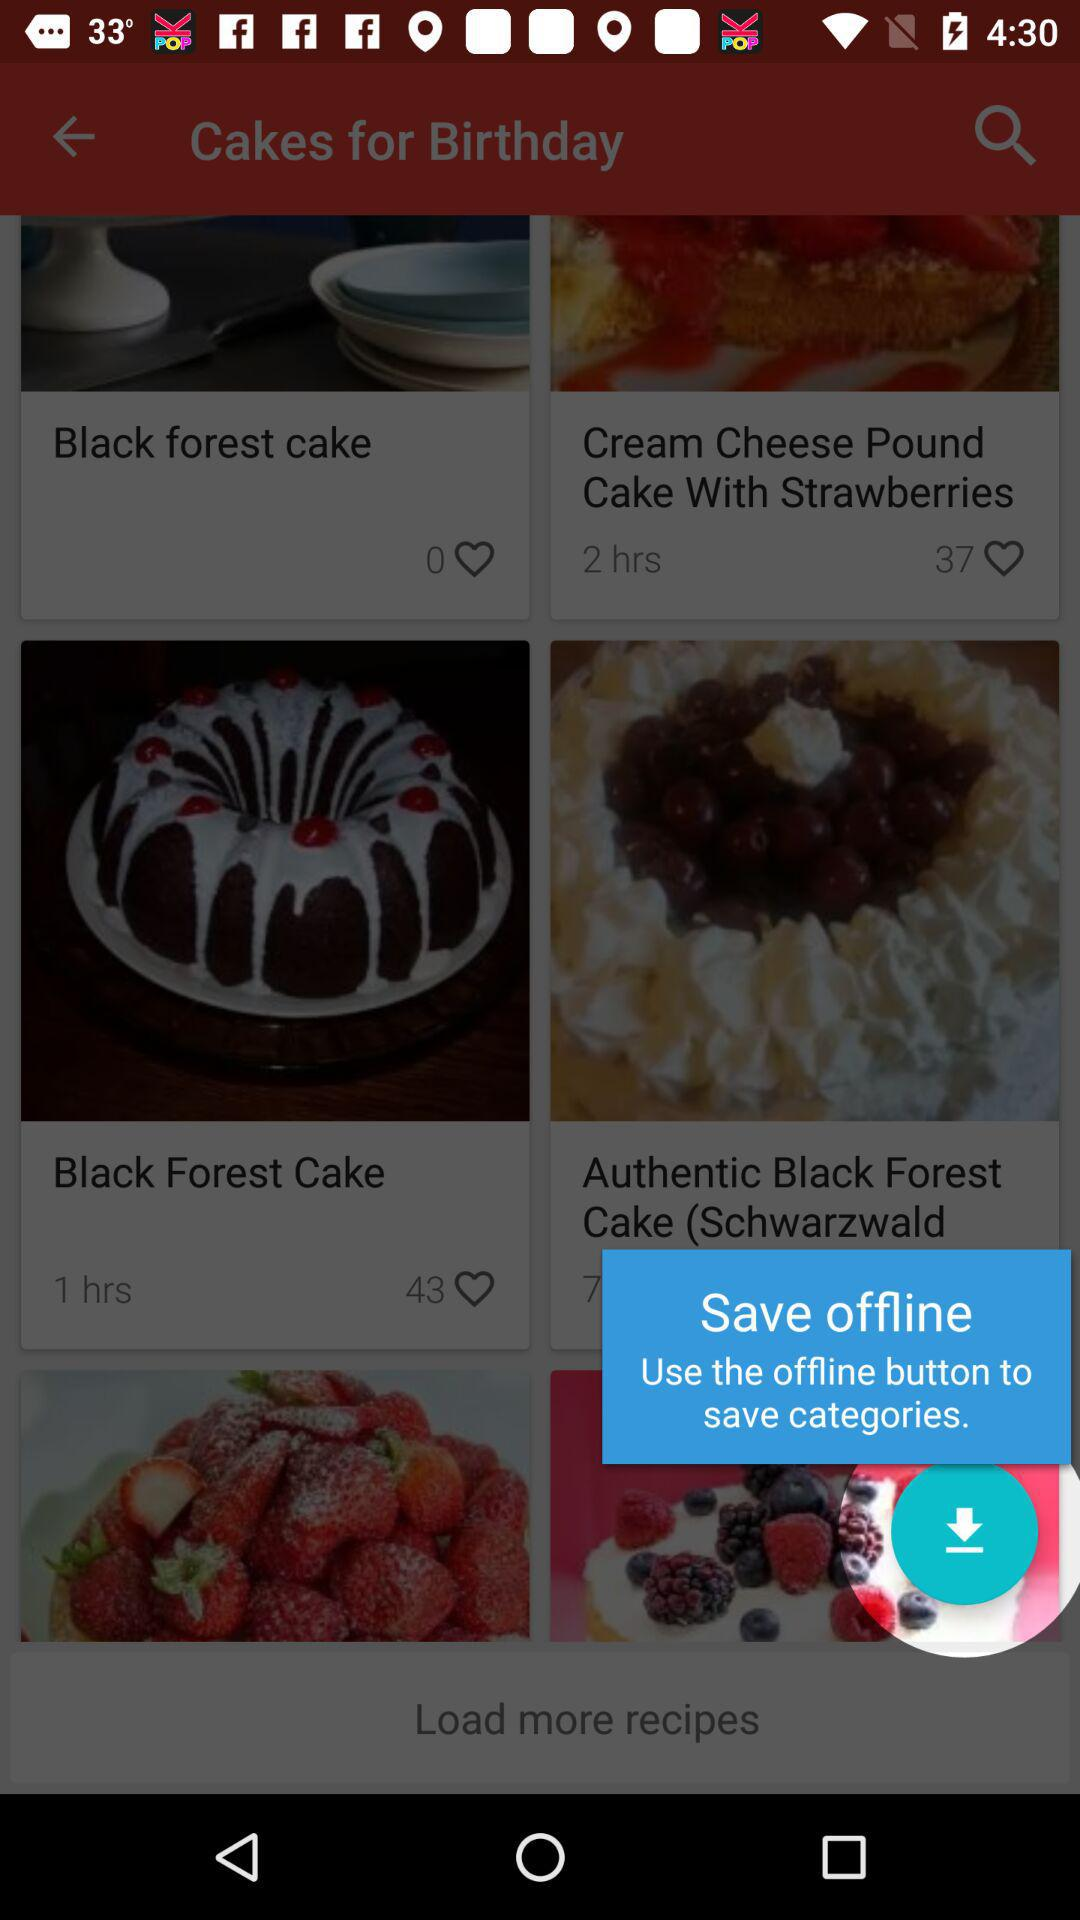How many likes are there for "Black Forest cake"? There are 0 likes for "Black Forest cake". 